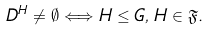<formula> <loc_0><loc_0><loc_500><loc_500>\ D ^ { H } \neq \emptyset \Longleftrightarrow H \leq G , \, H \in \mathfrak { F } .</formula> 